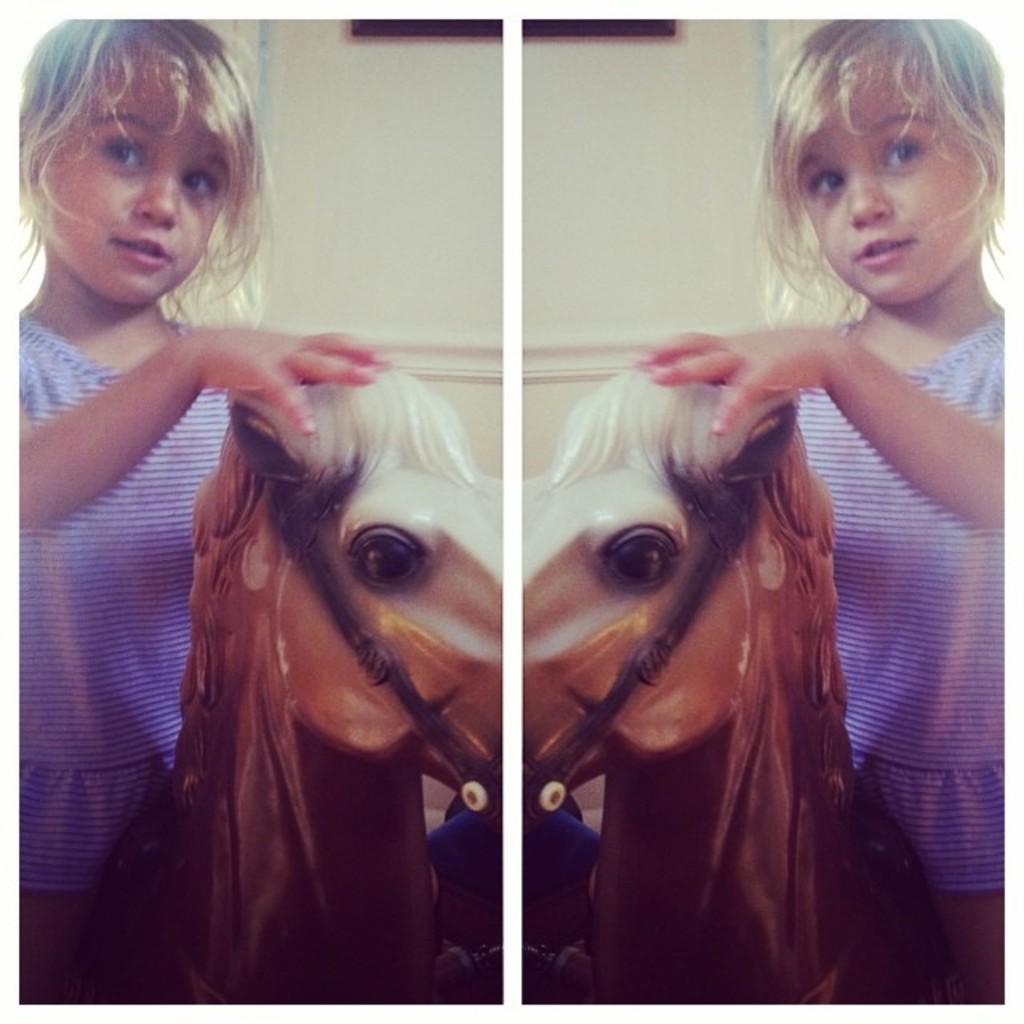In one or two sentences, can you explain what this image depicts? In this picture we can see a girl sitting on the horse. On the background there is a wall. 